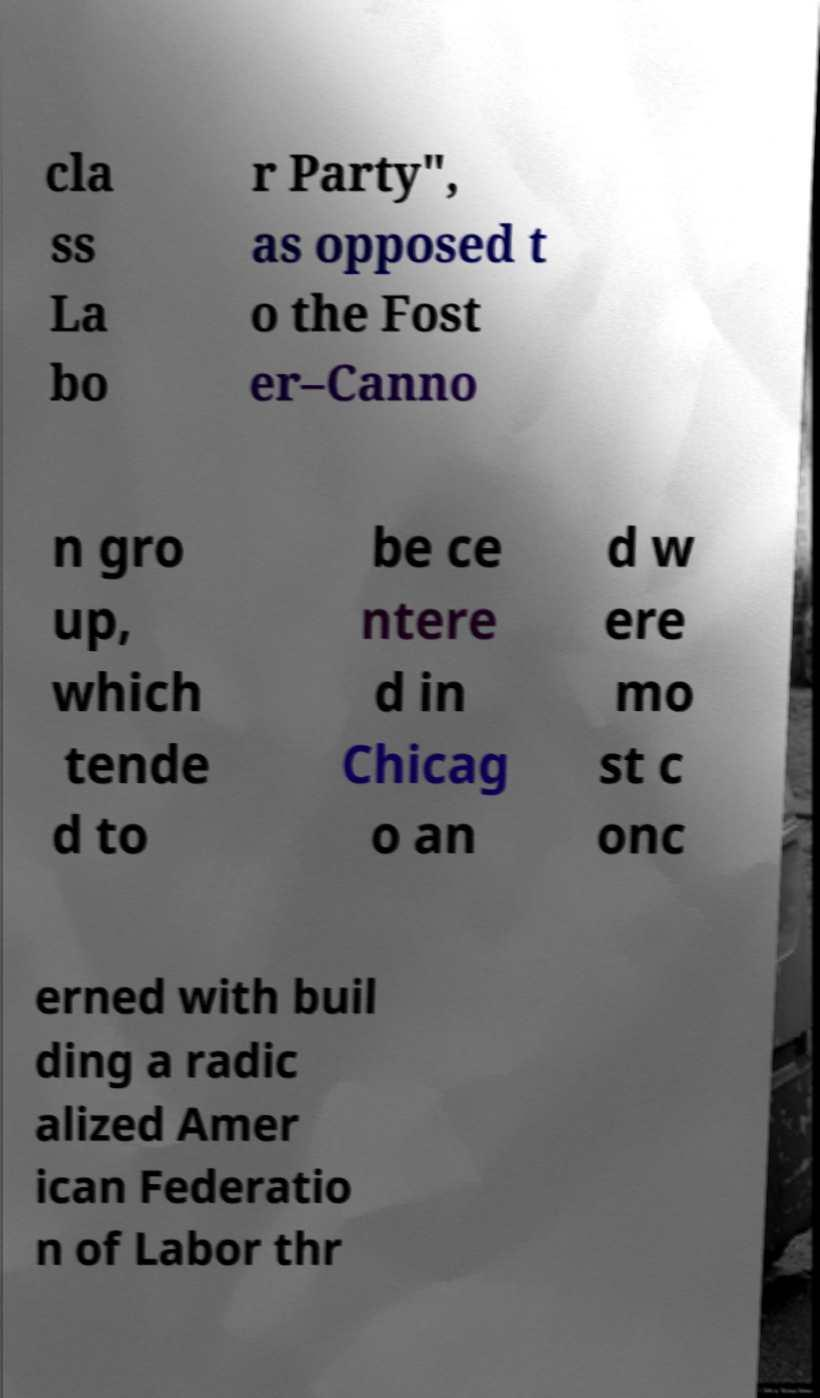For documentation purposes, I need the text within this image transcribed. Could you provide that? cla ss La bo r Party", as opposed t o the Fost er–Canno n gro up, which tende d to be ce ntere d in Chicag o an d w ere mo st c onc erned with buil ding a radic alized Amer ican Federatio n of Labor thr 